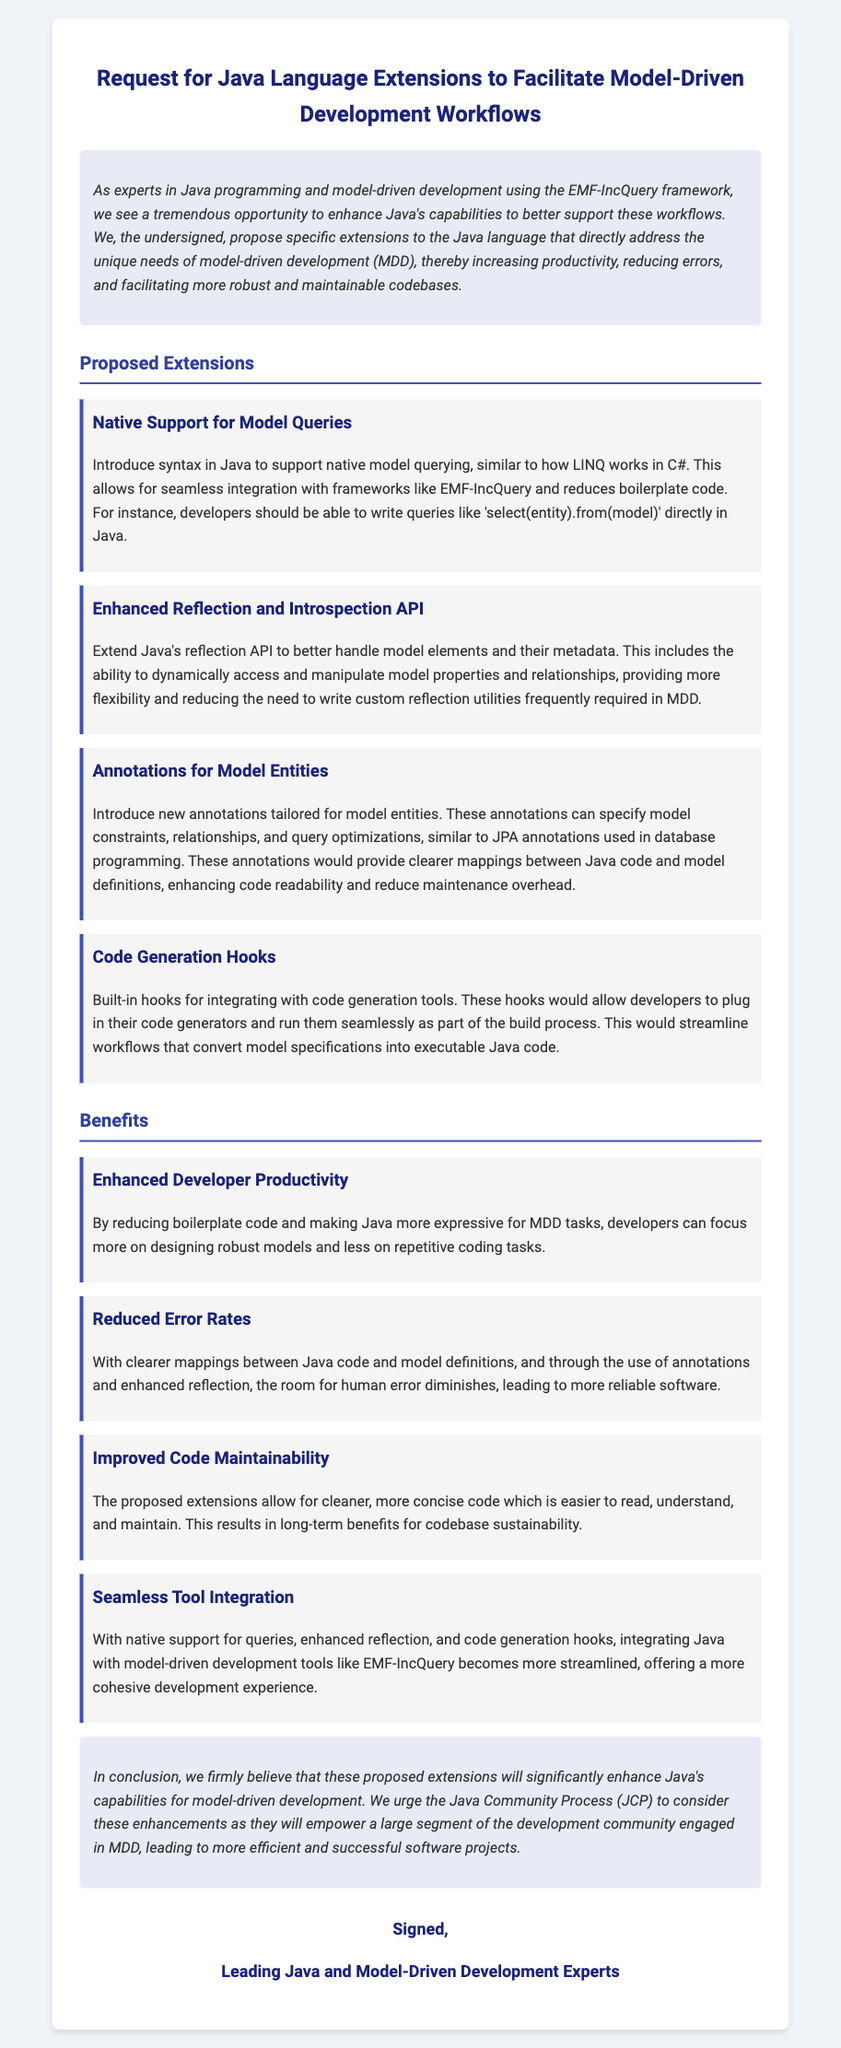What is the title of the petition? The title is explicitly stated at the beginning of the document.
Answer: Request for Java Language Extensions to Facilitate Model-Driven Development Workflows How many proposed extensions are mentioned? The document lists the proposed extensions under a specific heading.
Answer: Four What is the first proposed extension? The first proposed extension is detailed as the first item in the list.
Answer: Native Support for Model Queries What benefit relates to error rates? The documents contain a section on benefits which directly references error rates.
Answer: Reduced Error Rates Who is the petition aimed at? The conclusion of the document specifies the target audience.
Answer: Java Community Process (JCP) What is one of the advantages of the proposed code generation hooks? The document outlines specific benefits of the proposed extensions.
Answer: Streamline workflows What is the color scheme used in the document's styling? The document includes styles that inform about its visual presentation.
Answer: Blue and white What is a key theme mentioned in the introduction? The introduction outlines the main focus and motivation behind the petition.
Answer: Enhance Java's capabilities How is the signatories section labeled? The document has a designated label for the signatories section at the end.
Answer: Signed 